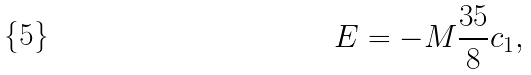<formula> <loc_0><loc_0><loc_500><loc_500>E = - M \frac { 3 5 } 8 c _ { 1 } ,</formula> 